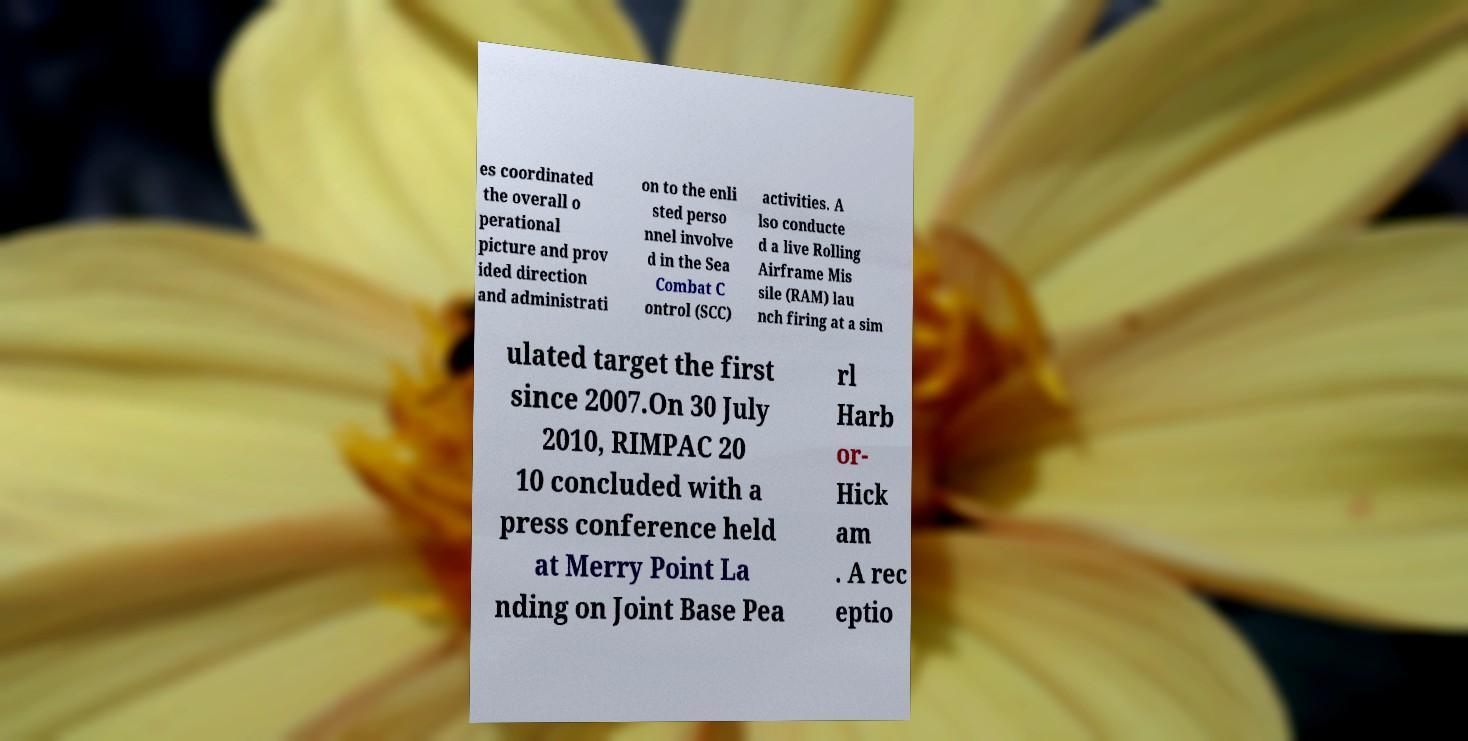What messages or text are displayed in this image? I need them in a readable, typed format. es coordinated the overall o perational picture and prov ided direction and administrati on to the enli sted perso nnel involve d in the Sea Combat C ontrol (SCC) activities. A lso conducte d a live Rolling Airframe Mis sile (RAM) lau nch firing at a sim ulated target the first since 2007.On 30 July 2010, RIMPAC 20 10 concluded with a press conference held at Merry Point La nding on Joint Base Pea rl Harb or- Hick am . A rec eptio 